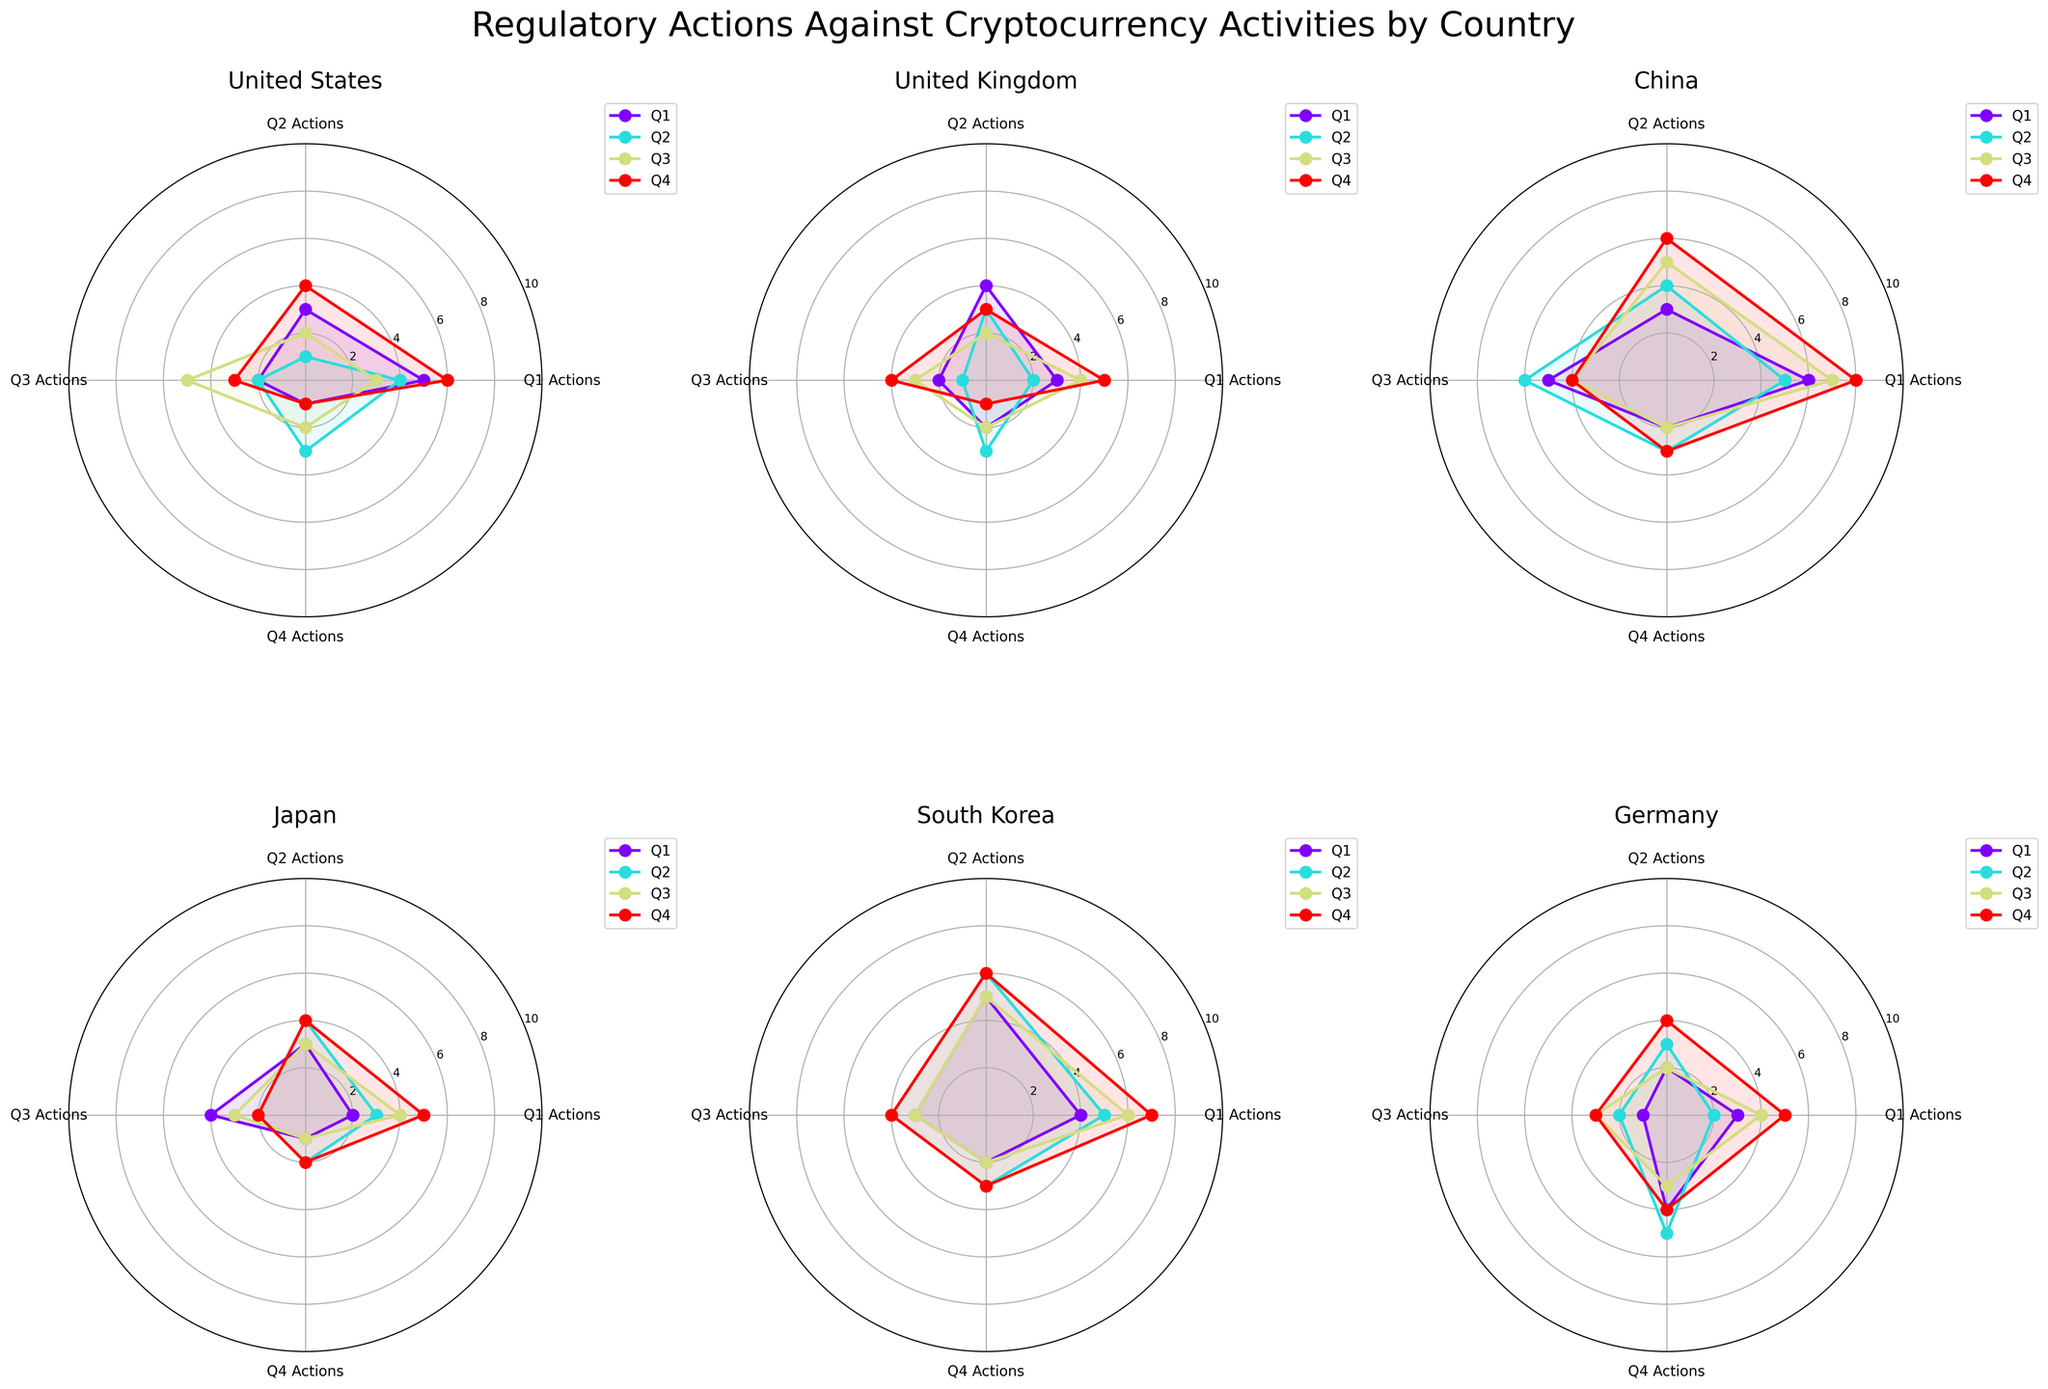How many regulatory actions did the United States take in Q3? The radar chart for the United States in Q3 shows a filled line reaching 3 actions for Q1 actions, 2 actions for Q2 actions, 5 actions for Q3 actions, and 2 actions again for Q4 actions.
Answer: 5 Which country had the highest number of regulatory actions in any single quarter? Looking across all the radar charts, China in Q4 shows the highest number of regulatory actions with lines reaching up to 8 for Q1 actions.
Answer: China What is the average number of Q2 actions taken by South Korea across all quarters? To find the average: South Korea's Q2 actions are 5 in Q1, 6 in Q2, 5 in Q3, and 6 in Q4. Calculate the average as (5+6+5+6)/4 = 5.5.
Answer: 5.5 Compare the Q4 actions between the United States and the United Kingdom in Q1. Which country has more? The Q4 actions in Q1 for the United States are represented by the line reaching 2, while for the United Kingdom, it is reaching 2 as well. Thus, they are equal.
Answer: Equal Which quarter generally has the highest regulatory actions for Japan? By looking at the radar chart for Japan, Q4 appears to have consistently higher action counts reaching up to 5 in Q1, Q4 in Q3, and so on.
Answer: Q4 What is the sum of Q1 and Q2 actions for Germany in Q2? Germany's radar chart for Q2 shows 2 Q1 actions and 3 Q2 actions. The sum is 2+3=5.
Answer: 5 How does the regulatory action trend for China in Q2 compare to Q4? China shows a decreasing trend from Q1 (5) to Q4 (3) in Q2 actions and a generally stable trend from Q1 (8) decreasing slightly to Q4 (4) in Q4 actions.
Answer: Decreasing Which country has the most balanced regulatory actions across all quarters? By observing the radar charts, Japan has actions evenly spread across Q1, Q2, Q3, and Q4 with not much variation.
Answer: Japan 